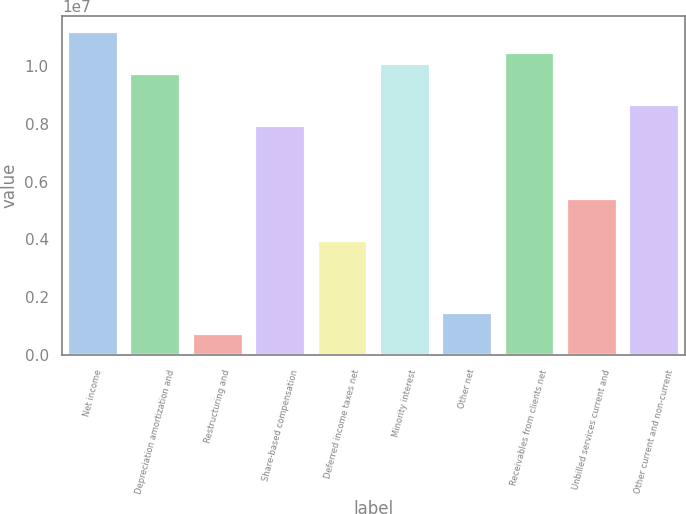Convert chart. <chart><loc_0><loc_0><loc_500><loc_500><bar_chart><fcel>Net income<fcel>Depreciation amortization and<fcel>Restructuring and<fcel>Share-based compensation<fcel>Deferred income taxes net<fcel>Minority interest<fcel>Other net<fcel>Receivables from clients net<fcel>Unbilled services current and<fcel>Other current and non-current<nl><fcel>1.11591e+07<fcel>9.71982e+06<fcel>724145<fcel>7.92068e+06<fcel>3.96259e+06<fcel>1.00796e+07<fcel>1.4438e+06<fcel>1.04395e+07<fcel>5.40189e+06<fcel>8.64034e+06<nl></chart> 